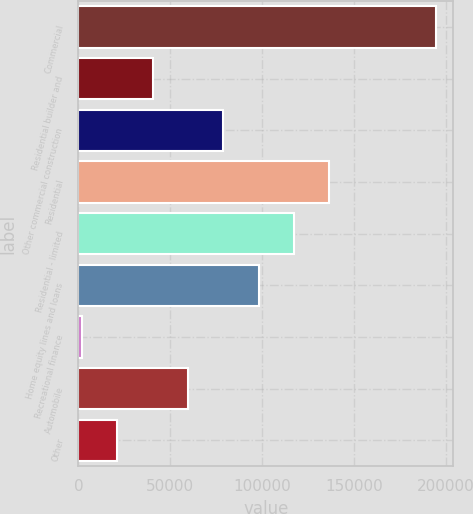Convert chart. <chart><loc_0><loc_0><loc_500><loc_500><bar_chart><fcel>Commercial<fcel>Residential builder and<fcel>Other commercial construction<fcel>Residential<fcel>Residential - limited<fcel>Home equity lines and loans<fcel>Recreational finance<fcel>Automobile<fcel>Other<nl><fcel>194451<fcel>40369.4<fcel>78889.8<fcel>136670<fcel>117410<fcel>98150<fcel>1849<fcel>59629.6<fcel>21109.2<nl></chart> 